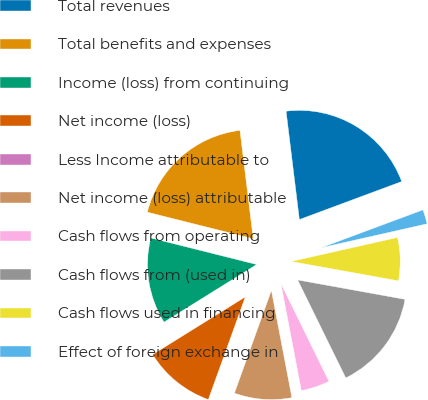Convert chart. <chart><loc_0><loc_0><loc_500><loc_500><pie_chart><fcel>Total revenues<fcel>Total benefits and expenses<fcel>Income (loss) from continuing<fcel>Net income (loss)<fcel>Less Income attributable to<fcel>Net income (loss) attributable<fcel>Cash flows from operating<fcel>Cash flows from (used in)<fcel>Cash flows used in financing<fcel>Effect of foreign exchange in<nl><fcel>21.28%<fcel>19.15%<fcel>12.77%<fcel>10.64%<fcel>0.0%<fcel>8.51%<fcel>4.26%<fcel>14.89%<fcel>6.38%<fcel>2.13%<nl></chart> 